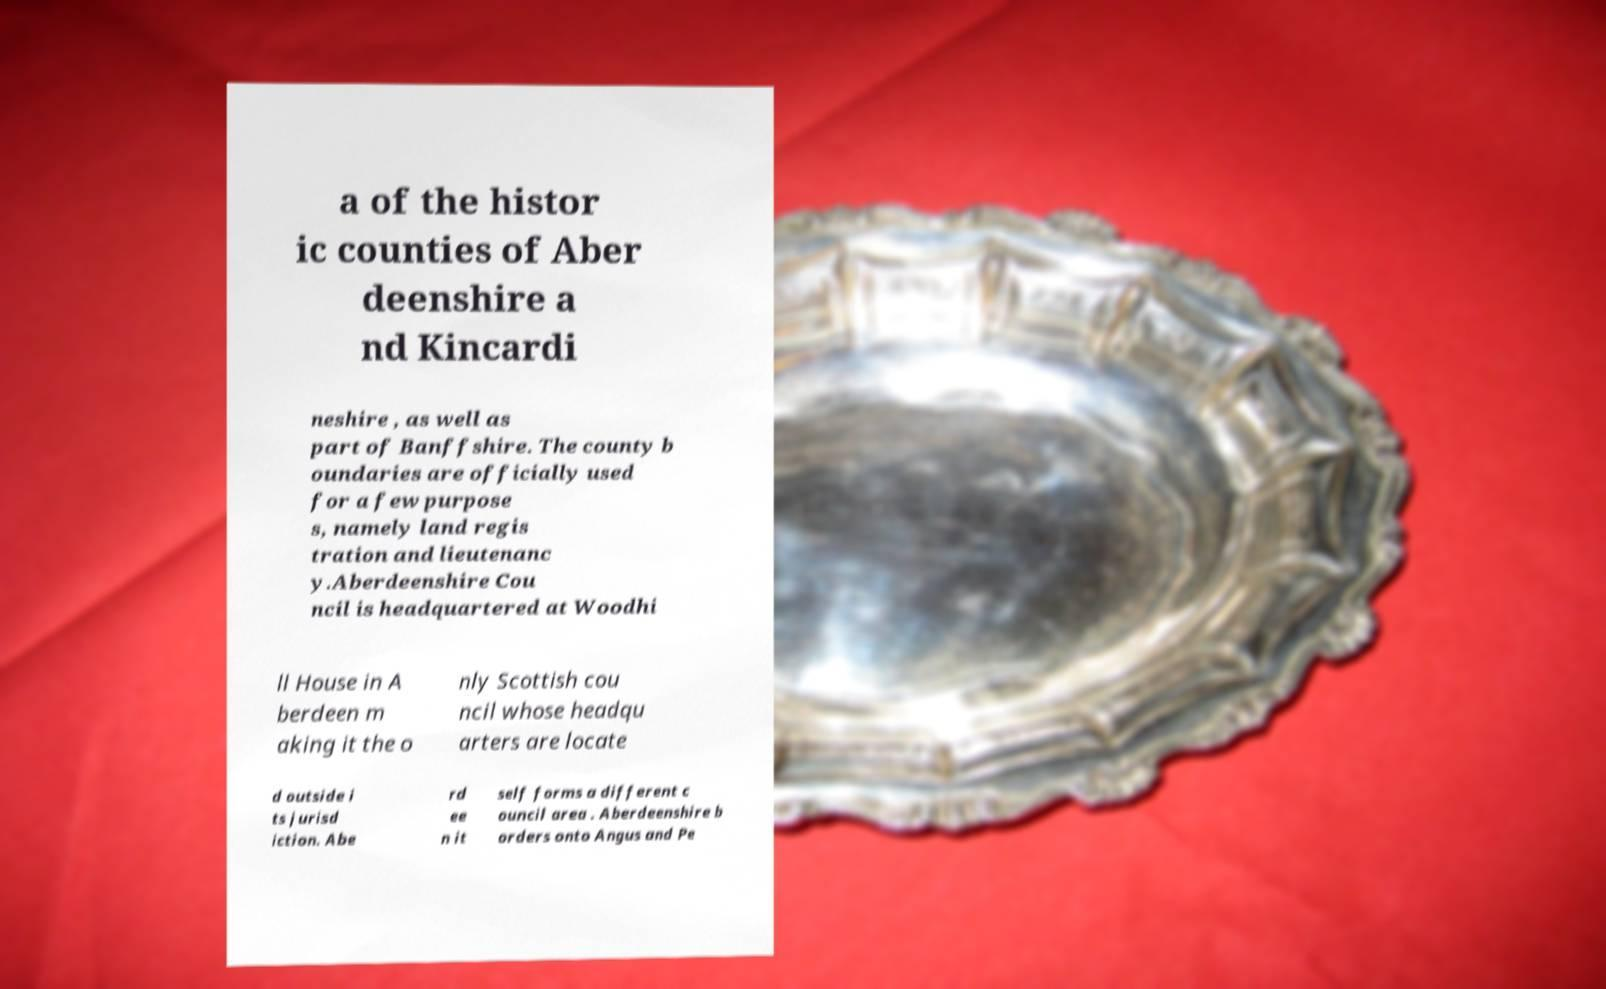Please read and relay the text visible in this image. What does it say? a of the histor ic counties of Aber deenshire a nd Kincardi neshire , as well as part of Banffshire. The county b oundaries are officially used for a few purpose s, namely land regis tration and lieutenanc y.Aberdeenshire Cou ncil is headquartered at Woodhi ll House in A berdeen m aking it the o nly Scottish cou ncil whose headqu arters are locate d outside i ts jurisd iction. Abe rd ee n it self forms a different c ouncil area . Aberdeenshire b orders onto Angus and Pe 